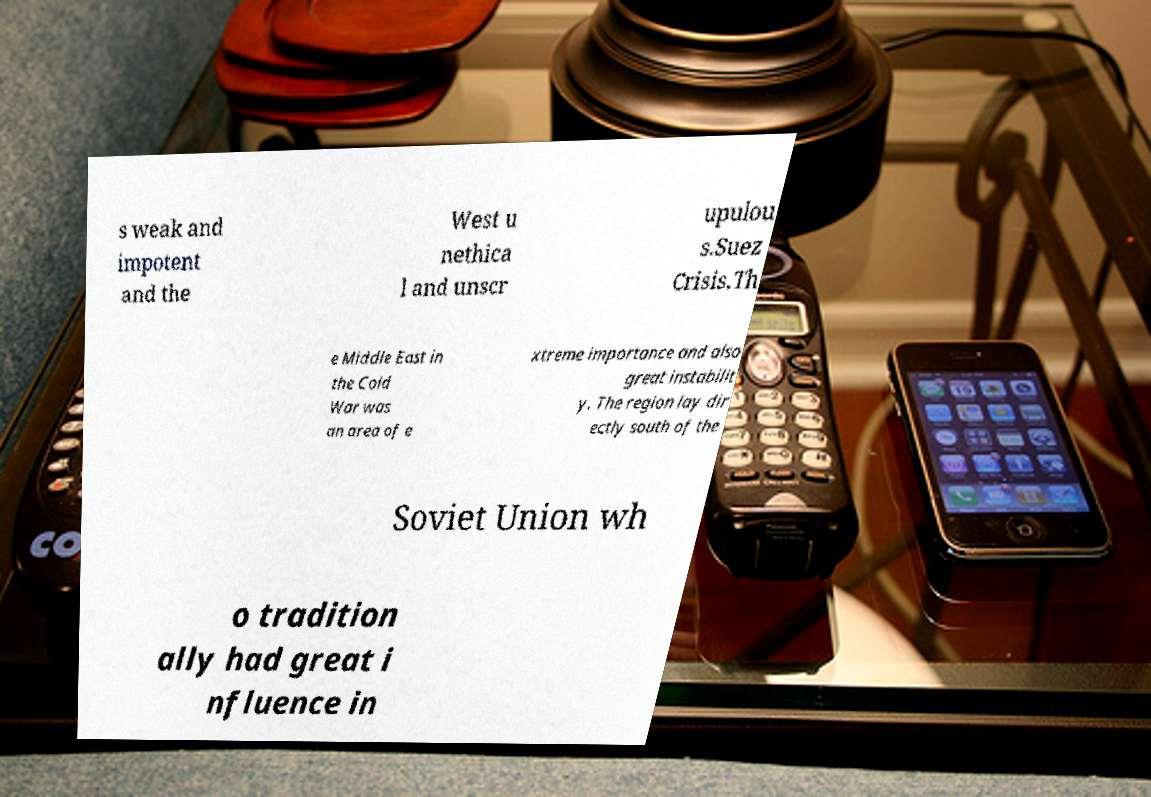Please identify and transcribe the text found in this image. s weak and impotent and the West u nethica l and unscr upulou s.Suez Crisis.Th e Middle East in the Cold War was an area of e xtreme importance and also great instabilit y. The region lay dir ectly south of the Soviet Union wh o tradition ally had great i nfluence in 